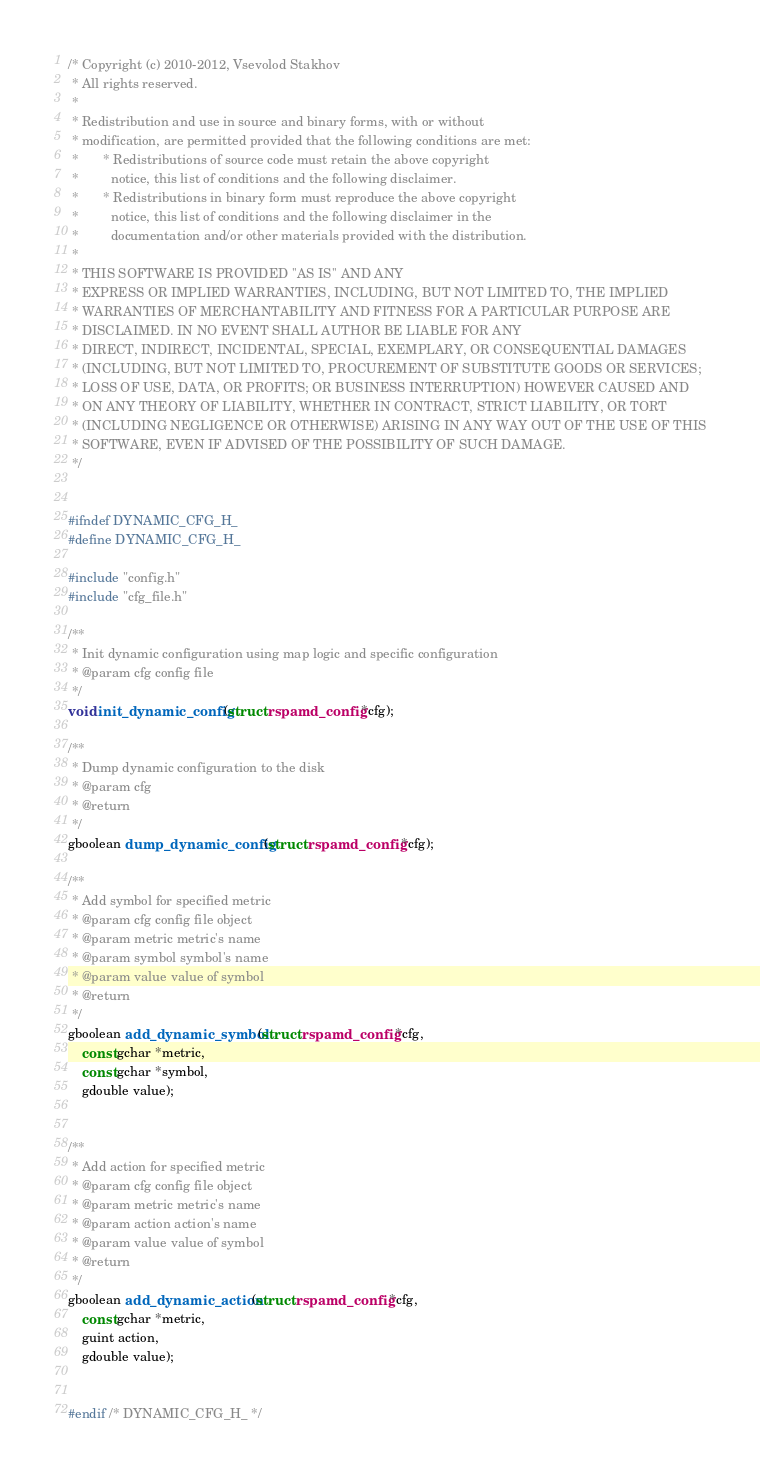<code> <loc_0><loc_0><loc_500><loc_500><_C_>/* Copyright (c) 2010-2012, Vsevolod Stakhov
 * All rights reserved.
 *
 * Redistribution and use in source and binary forms, with or without
 * modification, are permitted provided that the following conditions are met:
 *       * Redistributions of source code must retain the above copyright
 *         notice, this list of conditions and the following disclaimer.
 *       * Redistributions in binary form must reproduce the above copyright
 *         notice, this list of conditions and the following disclaimer in the
 *         documentation and/or other materials provided with the distribution.
 *
 * THIS SOFTWARE IS PROVIDED ''AS IS'' AND ANY
 * EXPRESS OR IMPLIED WARRANTIES, INCLUDING, BUT NOT LIMITED TO, THE IMPLIED
 * WARRANTIES OF MERCHANTABILITY AND FITNESS FOR A PARTICULAR PURPOSE ARE
 * DISCLAIMED. IN NO EVENT SHALL AUTHOR BE LIABLE FOR ANY
 * DIRECT, INDIRECT, INCIDENTAL, SPECIAL, EXEMPLARY, OR CONSEQUENTIAL DAMAGES
 * (INCLUDING, BUT NOT LIMITED TO, PROCUREMENT OF SUBSTITUTE GOODS OR SERVICES;
 * LOSS OF USE, DATA, OR PROFITS; OR BUSINESS INTERRUPTION) HOWEVER CAUSED AND
 * ON ANY THEORY OF LIABILITY, WHETHER IN CONTRACT, STRICT LIABILITY, OR TORT
 * (INCLUDING NEGLIGENCE OR OTHERWISE) ARISING IN ANY WAY OUT OF THE USE OF THIS
 * SOFTWARE, EVEN IF ADVISED OF THE POSSIBILITY OF SUCH DAMAGE.
 */


#ifndef DYNAMIC_CFG_H_
#define DYNAMIC_CFG_H_

#include "config.h"
#include "cfg_file.h"

/**
 * Init dynamic configuration using map logic and specific configuration
 * @param cfg config file
 */
void init_dynamic_config (struct rspamd_config *cfg);

/**
 * Dump dynamic configuration to the disk
 * @param cfg
 * @return
 */
gboolean dump_dynamic_config (struct rspamd_config *cfg);

/**
 * Add symbol for specified metric
 * @param cfg config file object
 * @param metric metric's name
 * @param symbol symbol's name
 * @param value value of symbol
 * @return
 */
gboolean add_dynamic_symbol (struct rspamd_config *cfg,
	const gchar *metric,
	const gchar *symbol,
	gdouble value);


/**
 * Add action for specified metric
 * @param cfg config file object
 * @param metric metric's name
 * @param action action's name
 * @param value value of symbol
 * @return
 */
gboolean add_dynamic_action (struct rspamd_config *cfg,
	const gchar *metric,
	guint action,
	gdouble value);


#endif /* DYNAMIC_CFG_H_ */
</code> 